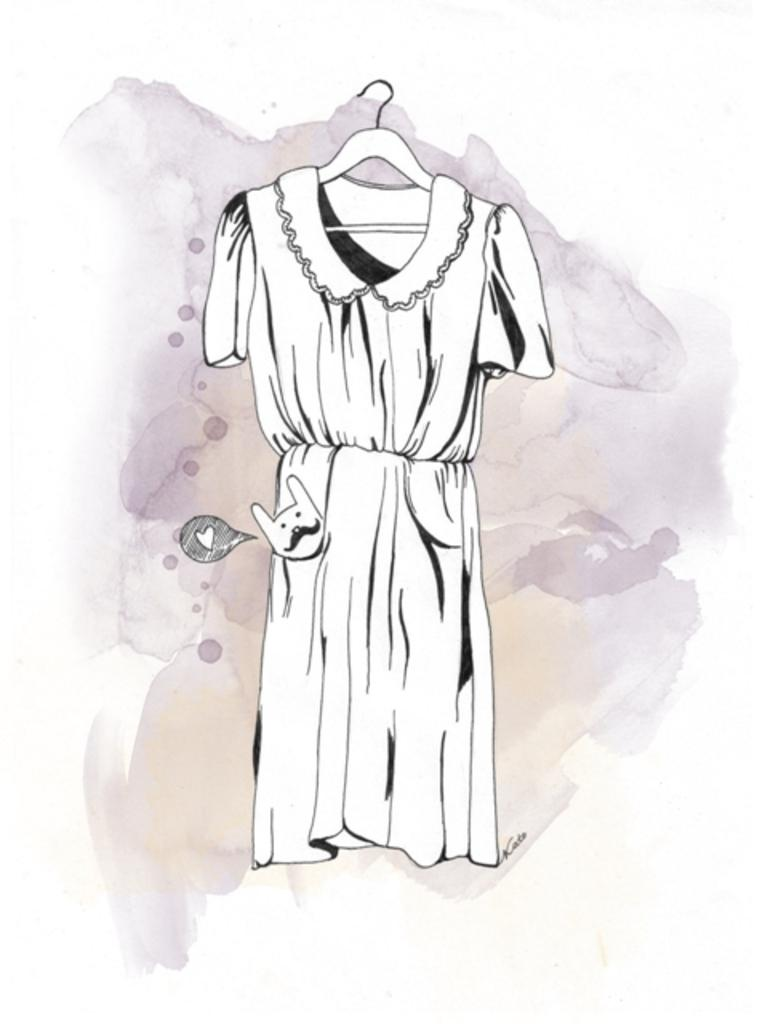What is depicted in the painting in the image? There is a painting of a dress in the image. What object is present in the image that might be used for hanging clothes? There is a hanger in the image. What else can be seen in the image besides the painting and hanger? There is some text in the image. How many letters are visible on the beast in the image? There is no beast present in the image, and therefore no letters can be observed on it. 